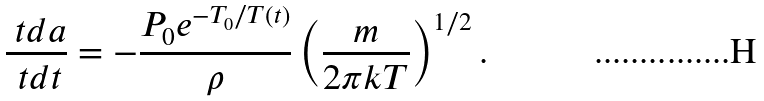<formula> <loc_0><loc_0><loc_500><loc_500>\frac { \ t d a } { \ t d t } = - \frac { P _ { 0 } e ^ { - T _ { 0 } / T ( t ) } } { \rho } \left ( \frac { m } { 2 \pi k T } \right ) ^ { 1 / 2 } .</formula> 